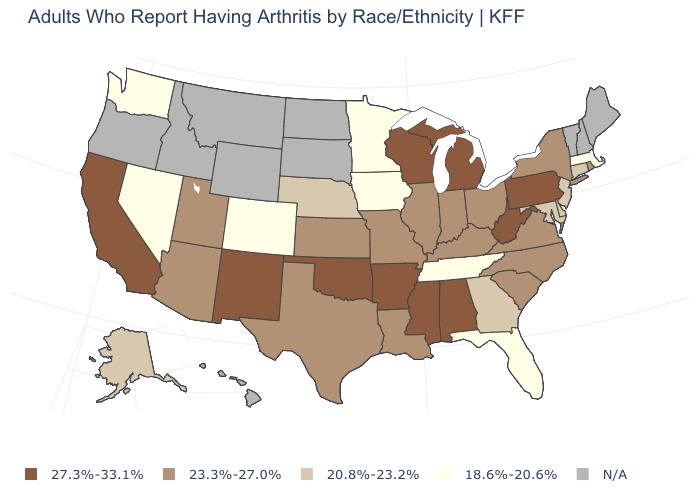What is the value of Hawaii?
Quick response, please. N/A. Does the map have missing data?
Answer briefly. Yes. How many symbols are there in the legend?
Give a very brief answer. 5. Is the legend a continuous bar?
Short answer required. No. Among the states that border Utah , does New Mexico have the highest value?
Answer briefly. Yes. Among the states that border North Carolina , which have the lowest value?
Answer briefly. Tennessee. Is the legend a continuous bar?
Short answer required. No. Which states have the lowest value in the Northeast?
Be succinct. Massachusetts. Which states hav the highest value in the MidWest?
Concise answer only. Michigan, Wisconsin. Among the states that border Indiana , which have the highest value?
Concise answer only. Michigan. Name the states that have a value in the range 27.3%-33.1%?
Concise answer only. Alabama, Arkansas, California, Michigan, Mississippi, New Mexico, Oklahoma, Pennsylvania, West Virginia, Wisconsin. Name the states that have a value in the range N/A?
Give a very brief answer. Hawaii, Idaho, Maine, Montana, New Hampshire, North Dakota, Oregon, South Dakota, Vermont, Wyoming. Does Indiana have the highest value in the USA?
Keep it brief. No. Among the states that border Pennsylvania , which have the highest value?
Concise answer only. West Virginia. 